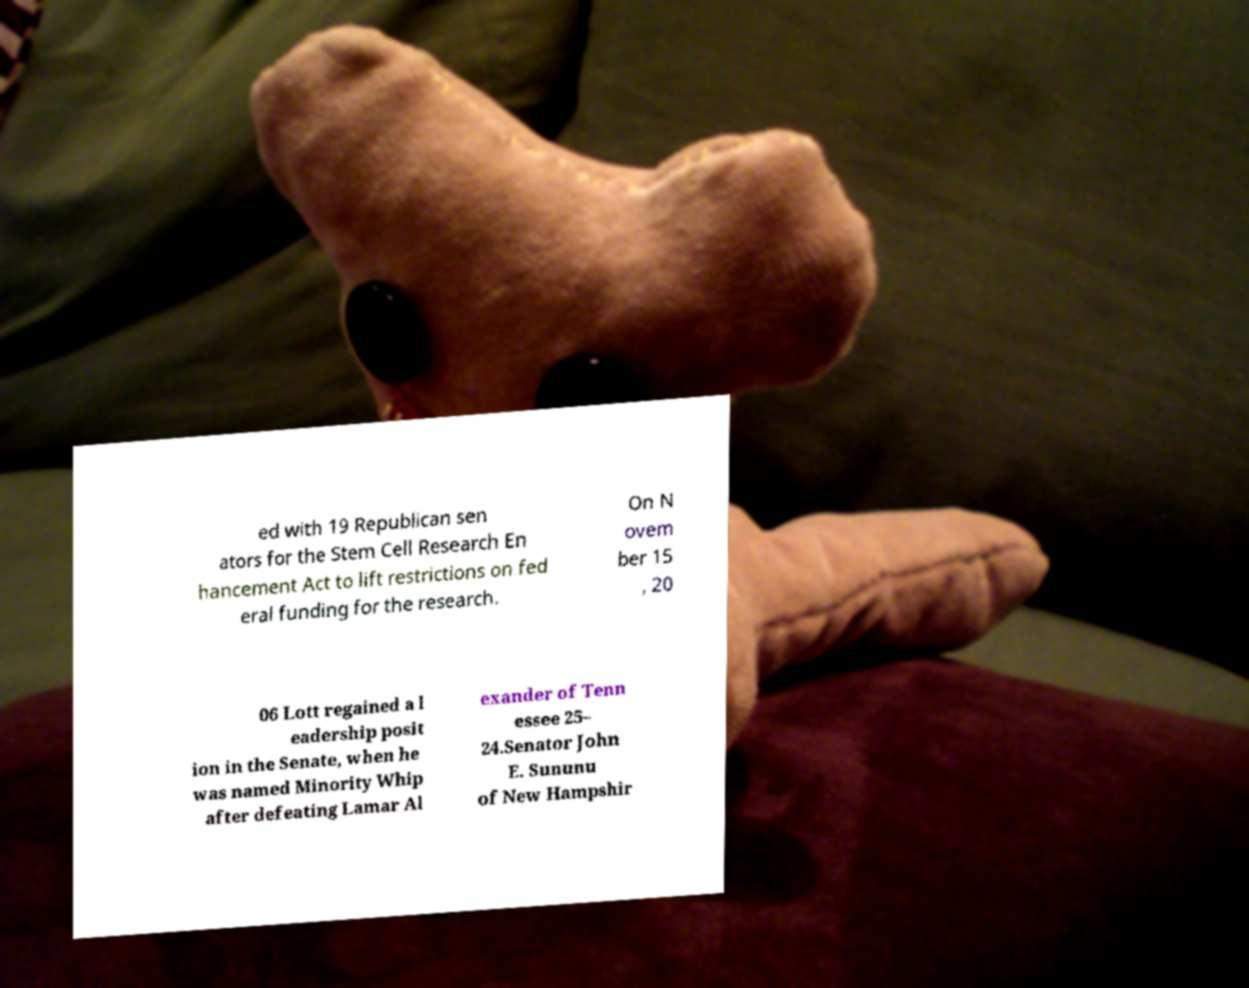Could you assist in decoding the text presented in this image and type it out clearly? ed with 19 Republican sen ators for the Stem Cell Research En hancement Act to lift restrictions on fed eral funding for the research. On N ovem ber 15 , 20 06 Lott regained a l eadership posit ion in the Senate, when he was named Minority Whip after defeating Lamar Al exander of Tenn essee 25– 24.Senator John E. Sununu of New Hampshir 